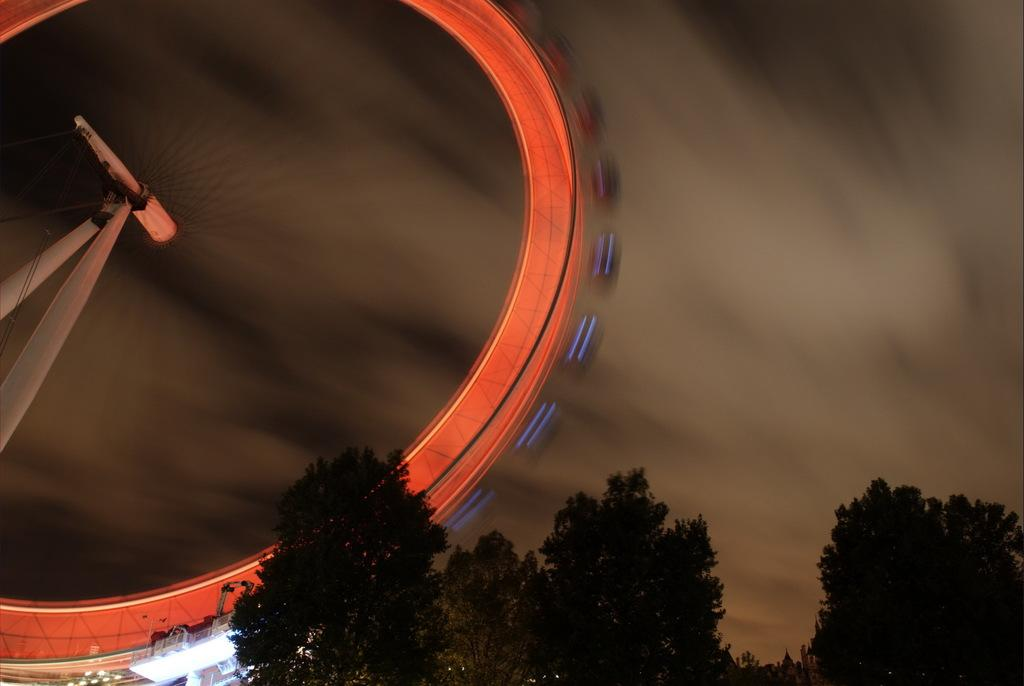What is the main structure located on the left side of the image? There is a giant wheel on the left side of the image. What type of vegetation can be seen at the bottom of the image? There are trees in the bottom of the image. What is visible in the background of the image? The sky is visible in the background of the image. Can you tell me what type of pump is being used by the judge in the image? There is no pump or judge present in the image; it features a giant wheel and trees. 